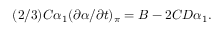Convert formula to latex. <formula><loc_0><loc_0><loc_500><loc_500>( 2 / 3 ) C \alpha _ { 1 } ( \partial \alpha / \partial { t } ) _ { \pi } = B - 2 C D \alpha _ { 1 } .</formula> 